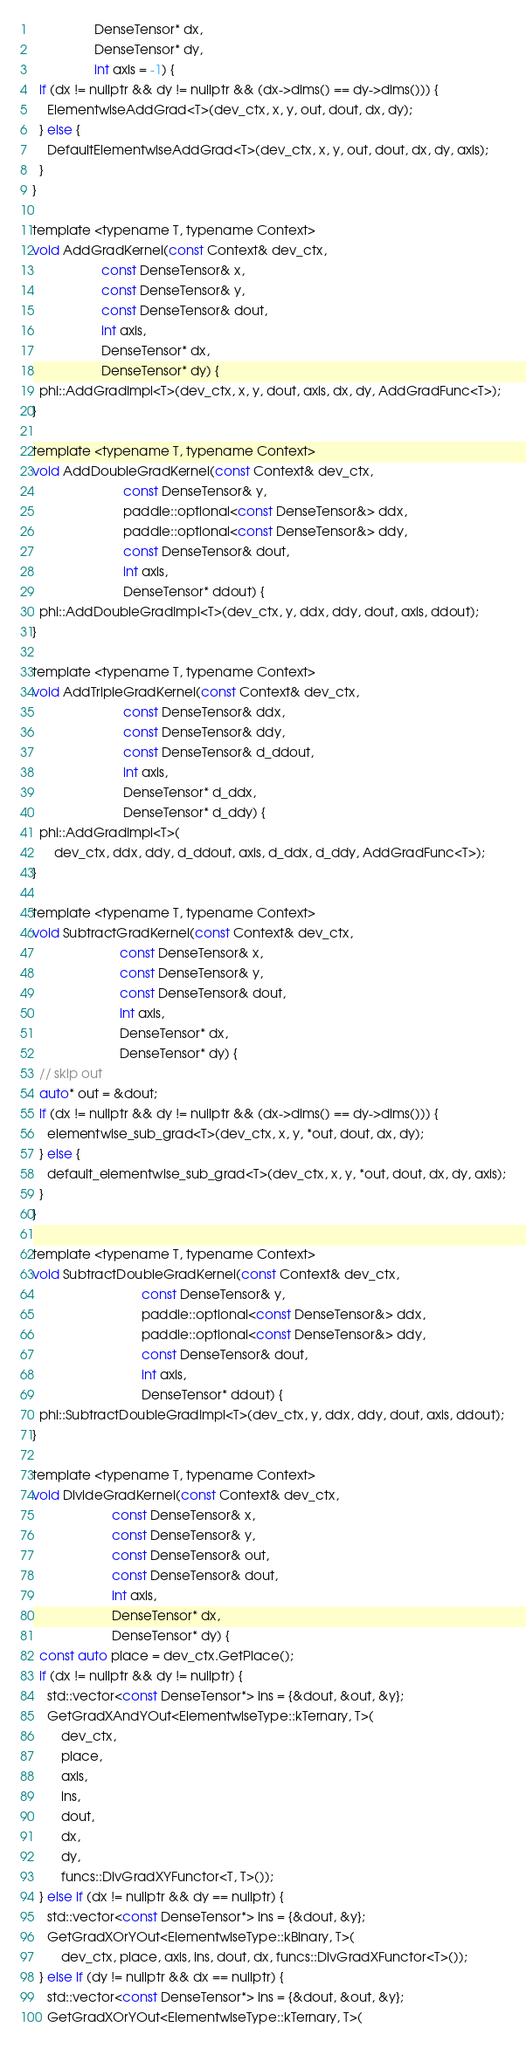<code> <loc_0><loc_0><loc_500><loc_500><_Cuda_>                 DenseTensor* dx,
                 DenseTensor* dy,
                 int axis = -1) {
  if (dx != nullptr && dy != nullptr && (dx->dims() == dy->dims())) {
    ElementwiseAddGrad<T>(dev_ctx, x, y, out, dout, dx, dy);
  } else {
    DefaultElementwiseAddGrad<T>(dev_ctx, x, y, out, dout, dx, dy, axis);
  }
}

template <typename T, typename Context>
void AddGradKernel(const Context& dev_ctx,
                   const DenseTensor& x,
                   const DenseTensor& y,
                   const DenseTensor& dout,
                   int axis,
                   DenseTensor* dx,
                   DenseTensor* dy) {
  phi::AddGradImpl<T>(dev_ctx, x, y, dout, axis, dx, dy, AddGradFunc<T>);
}

template <typename T, typename Context>
void AddDoubleGradKernel(const Context& dev_ctx,
                         const DenseTensor& y,
                         paddle::optional<const DenseTensor&> ddx,
                         paddle::optional<const DenseTensor&> ddy,
                         const DenseTensor& dout,
                         int axis,
                         DenseTensor* ddout) {
  phi::AddDoubleGradImpl<T>(dev_ctx, y, ddx, ddy, dout, axis, ddout);
}

template <typename T, typename Context>
void AddTripleGradKernel(const Context& dev_ctx,
                         const DenseTensor& ddx,
                         const DenseTensor& ddy,
                         const DenseTensor& d_ddout,
                         int axis,
                         DenseTensor* d_ddx,
                         DenseTensor* d_ddy) {
  phi::AddGradImpl<T>(
      dev_ctx, ddx, ddy, d_ddout, axis, d_ddx, d_ddy, AddGradFunc<T>);
}

template <typename T, typename Context>
void SubtractGradKernel(const Context& dev_ctx,
                        const DenseTensor& x,
                        const DenseTensor& y,
                        const DenseTensor& dout,
                        int axis,
                        DenseTensor* dx,
                        DenseTensor* dy) {
  // skip out
  auto* out = &dout;
  if (dx != nullptr && dy != nullptr && (dx->dims() == dy->dims())) {
    elementwise_sub_grad<T>(dev_ctx, x, y, *out, dout, dx, dy);
  } else {
    default_elementwise_sub_grad<T>(dev_ctx, x, y, *out, dout, dx, dy, axis);
  }
}

template <typename T, typename Context>
void SubtractDoubleGradKernel(const Context& dev_ctx,
                              const DenseTensor& y,
                              paddle::optional<const DenseTensor&> ddx,
                              paddle::optional<const DenseTensor&> ddy,
                              const DenseTensor& dout,
                              int axis,
                              DenseTensor* ddout) {
  phi::SubtractDoubleGradImpl<T>(dev_ctx, y, ddx, ddy, dout, axis, ddout);
}

template <typename T, typename Context>
void DivideGradKernel(const Context& dev_ctx,
                      const DenseTensor& x,
                      const DenseTensor& y,
                      const DenseTensor& out,
                      const DenseTensor& dout,
                      int axis,
                      DenseTensor* dx,
                      DenseTensor* dy) {
  const auto place = dev_ctx.GetPlace();
  if (dx != nullptr && dy != nullptr) {
    std::vector<const DenseTensor*> ins = {&dout, &out, &y};
    GetGradXAndYOut<ElementwiseType::kTernary, T>(
        dev_ctx,
        place,
        axis,
        ins,
        dout,
        dx,
        dy,
        funcs::DivGradXYFunctor<T, T>());
  } else if (dx != nullptr && dy == nullptr) {
    std::vector<const DenseTensor*> ins = {&dout, &y};
    GetGradXOrYOut<ElementwiseType::kBinary, T>(
        dev_ctx, place, axis, ins, dout, dx, funcs::DivGradXFunctor<T>());
  } else if (dy != nullptr && dx == nullptr) {
    std::vector<const DenseTensor*> ins = {&dout, &out, &y};
    GetGradXOrYOut<ElementwiseType::kTernary, T>(</code> 